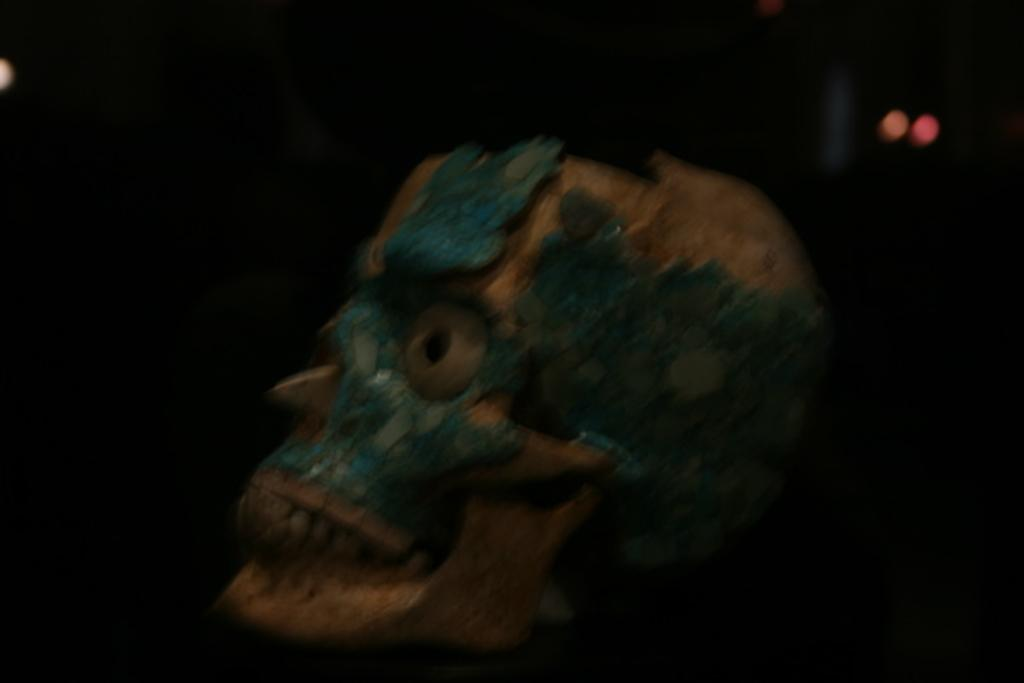What is the main subject of the image? The main subject of the image is a skull. What is the color or tone of the background in the image? The background of the image is dark. How many jellyfish can be seen swimming in the background of the image? There are no jellyfish present in the image. What type of footwear is visible on the skull in the image? There is no footwear visible on the skull in the image. 